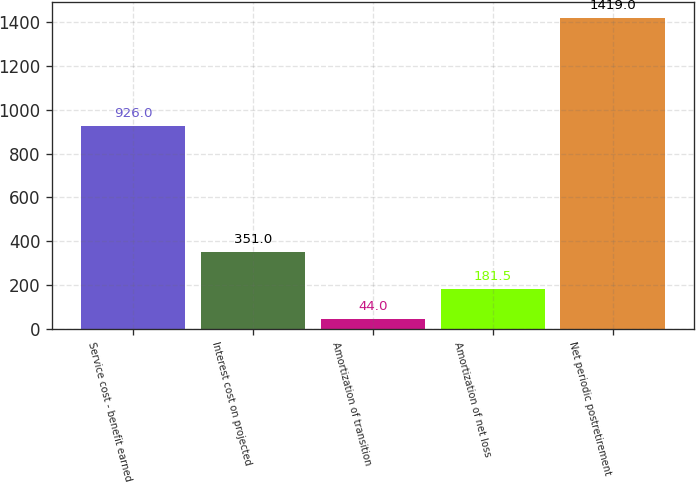Convert chart. <chart><loc_0><loc_0><loc_500><loc_500><bar_chart><fcel>Service cost - benefit earned<fcel>Interest cost on projected<fcel>Amortization of transition<fcel>Amortization of net loss<fcel>Net periodic postretirement<nl><fcel>926<fcel>351<fcel>44<fcel>181.5<fcel>1419<nl></chart> 